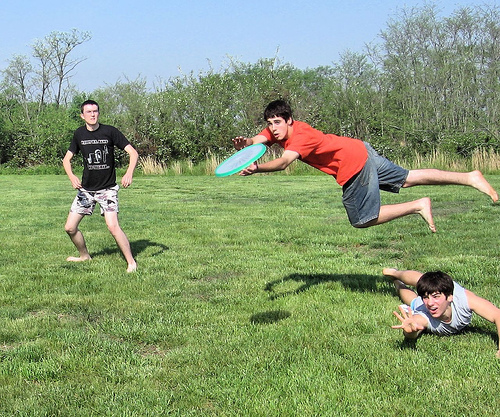Please provide a short description for this region: [0.14, 0.34, 0.23, 0.44]. A boy wearing a black shirt. 